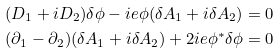Convert formula to latex. <formula><loc_0><loc_0><loc_500><loc_500>& ( D _ { 1 } + i D _ { 2 } ) \delta \phi - i e \phi ( \delta A _ { 1 } + i \delta A _ { 2 } ) = 0 \\ & ( \partial _ { 1 } - \partial _ { 2 } ) ( \delta A _ { 1 } + i \delta A _ { 2 } ) + 2 i e \phi ^ { * } \delta \phi = 0</formula> 